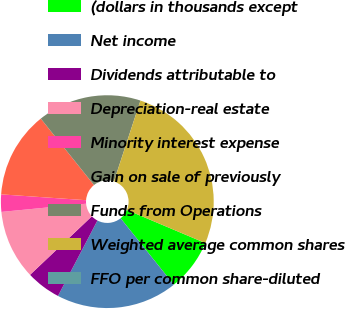Convert chart. <chart><loc_0><loc_0><loc_500><loc_500><pie_chart><fcel>(dollars in thousands except<fcel>Net income<fcel>Dividends attributable to<fcel>Depreciation-real estate<fcel>Minority interest expense<fcel>Gain on sale of previously<fcel>Funds from Operations<fcel>Weighted average common shares<fcel>FFO per common share-diluted<nl><fcel>7.89%<fcel>18.42%<fcel>5.26%<fcel>10.53%<fcel>2.63%<fcel>13.16%<fcel>15.79%<fcel>26.32%<fcel>0.0%<nl></chart> 